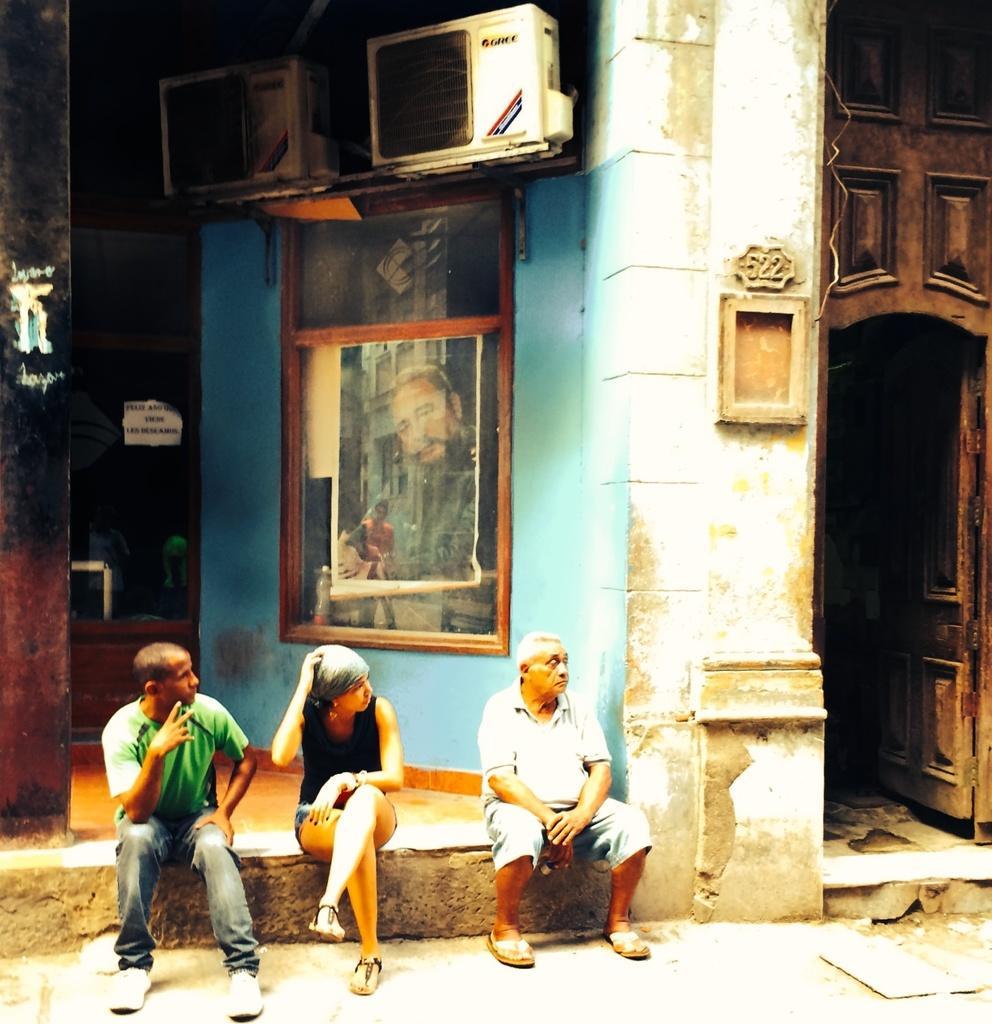How would you summarize this image in a sentence or two? In this picture there are persons sitting on stone. On the wall there is a frame and there are AC outdoor unit on the top. On the left side there is a door. 